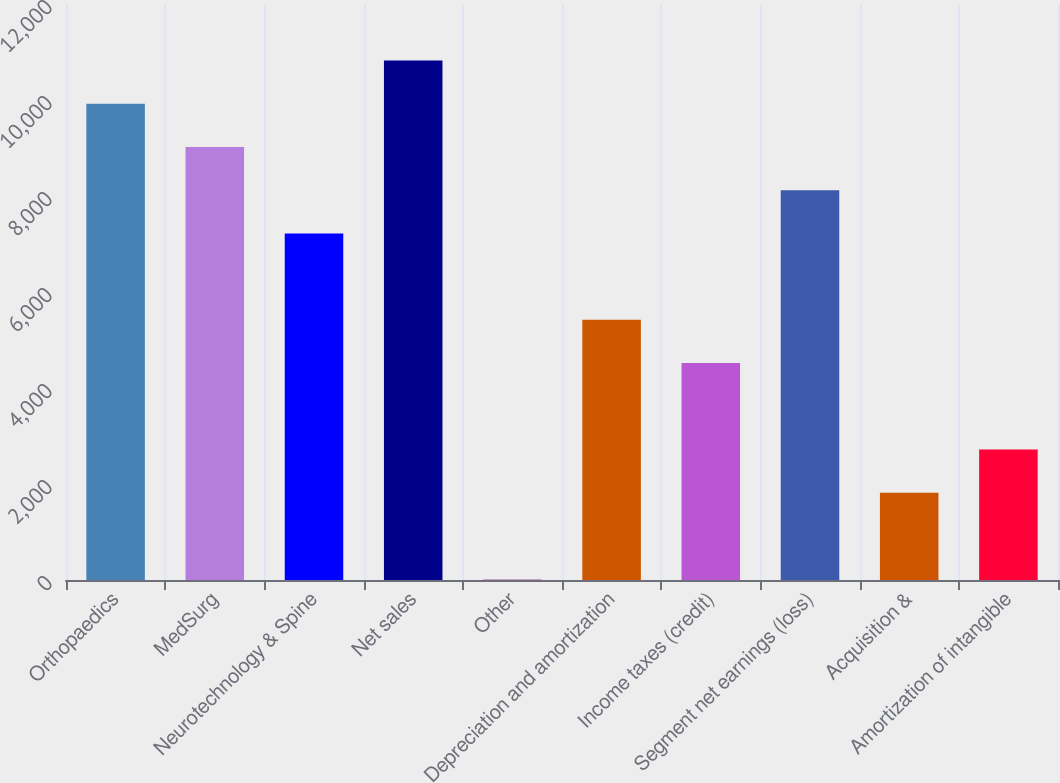Convert chart. <chart><loc_0><loc_0><loc_500><loc_500><bar_chart><fcel>Orthopaedics<fcel>MedSurg<fcel>Neurotechnology & Spine<fcel>Net sales<fcel>Other<fcel>Depreciation and amortization<fcel>Income taxes (credit)<fcel>Segment net earnings (loss)<fcel>Acquisition &<fcel>Amortization of intangible<nl><fcel>9921.2<fcel>9021<fcel>7220.6<fcel>10821.4<fcel>19<fcel>5420.2<fcel>4520<fcel>8120.8<fcel>1819.4<fcel>2719.6<nl></chart> 